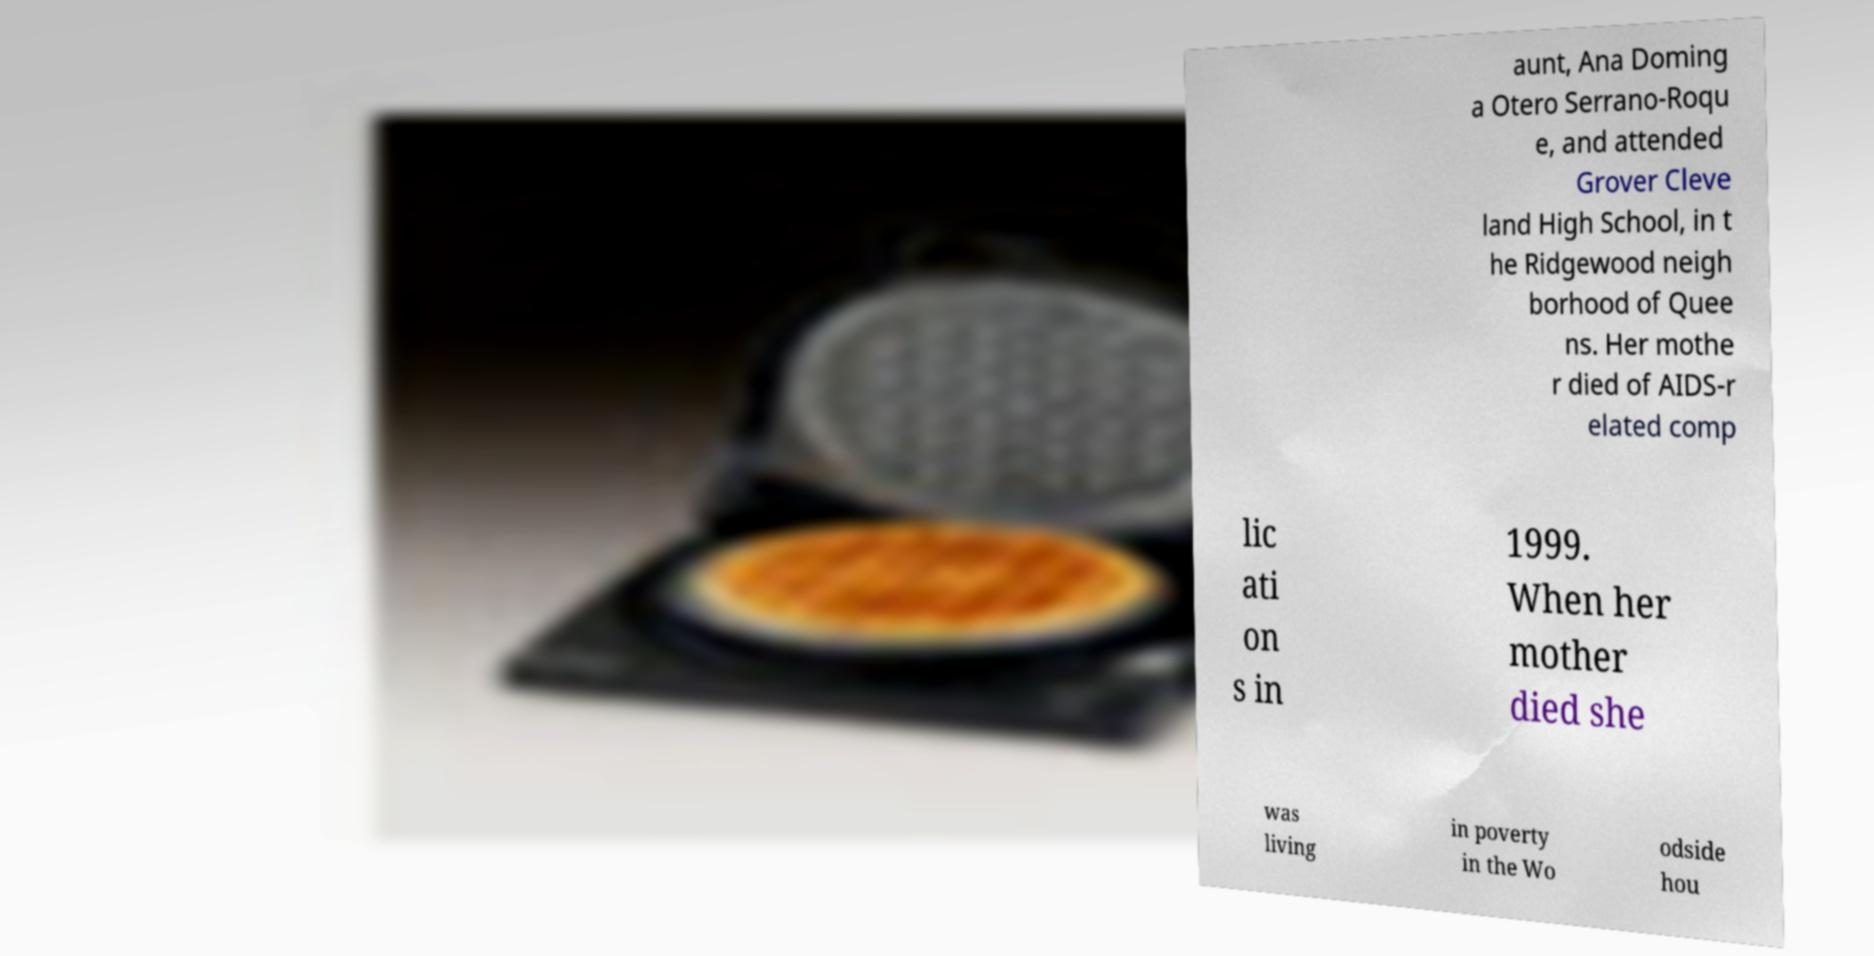Could you assist in decoding the text presented in this image and type it out clearly? aunt, Ana Doming a Otero Serrano-Roqu e, and attended Grover Cleve land High School, in t he Ridgewood neigh borhood of Quee ns. Her mothe r died of AIDS-r elated comp lic ati on s in 1999. When her mother died she was living in poverty in the Wo odside hou 